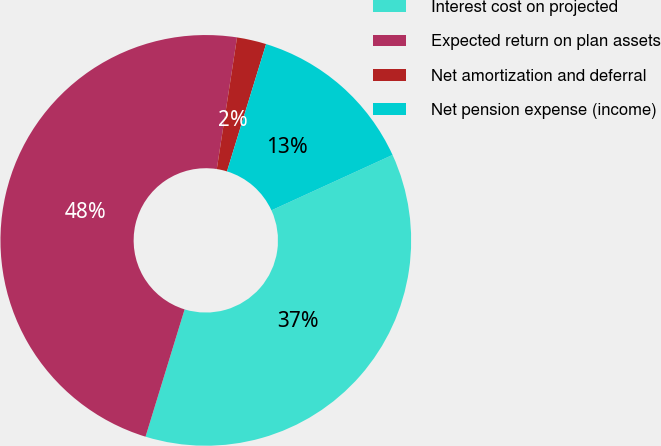Convert chart. <chart><loc_0><loc_0><loc_500><loc_500><pie_chart><fcel>Interest cost on projected<fcel>Expected return on plan assets<fcel>Net amortization and deferral<fcel>Net pension expense (income)<nl><fcel>36.57%<fcel>47.69%<fcel>2.31%<fcel>13.43%<nl></chart> 